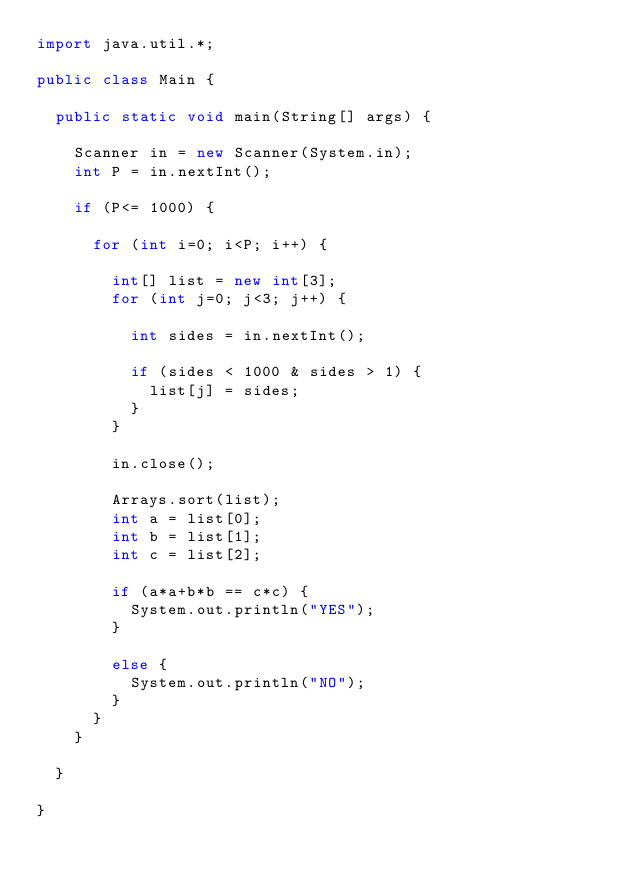<code> <loc_0><loc_0><loc_500><loc_500><_Java_>import java.util.*;

public class Main {

	public static void main(String[] args) {
		
		Scanner in = new Scanner(System.in);
		int P = in.nextInt();
		
		if (P<= 1000) {
			
			for (int i=0; i<P; i++) {
				
				int[] list = new int[3];
				for (int j=0; j<3; j++) {
	
					int sides = in.nextInt();
					
					if (sides < 1000 & sides > 1) {
						list[j] = sides;
					}
				}
				
				in.close();
				
				Arrays.sort(list);
				int a = list[0];
				int b = list[1];
				int c = list[2];
				
				if (a*a+b*b == c*c) {
					System.out.println("YES");
				}
				
				else {
					System.out.println("NO");
				}
			}
		}
					
	}

}</code> 